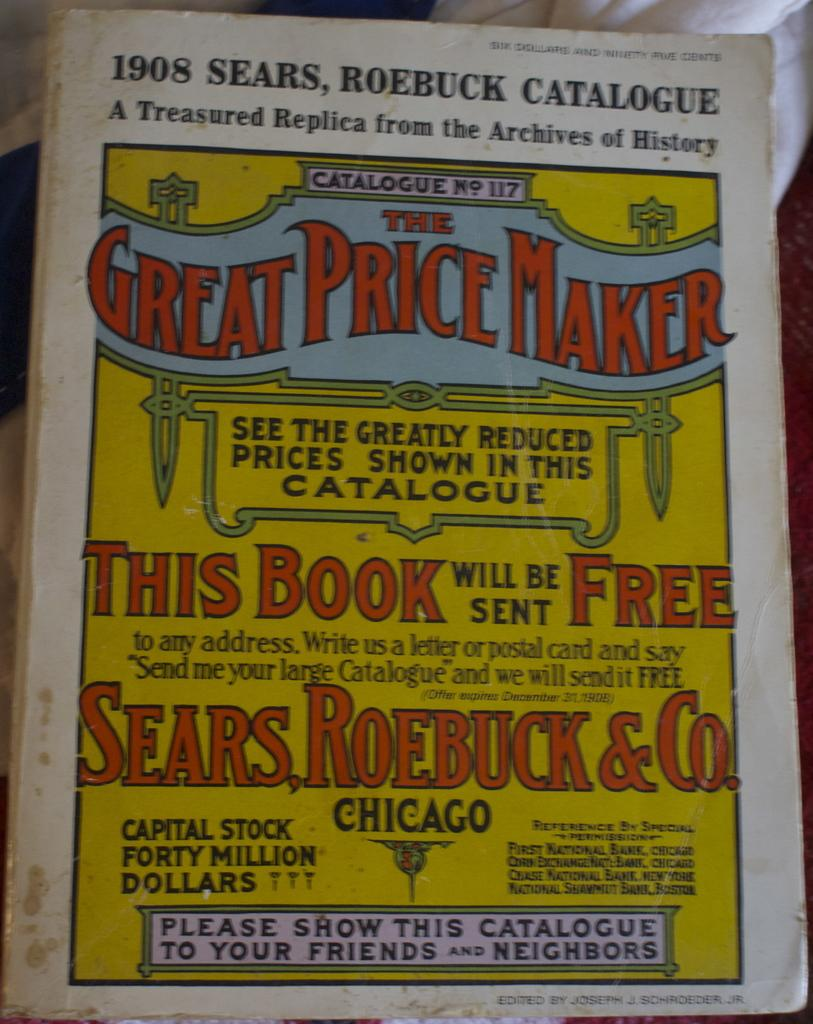What object can be seen in the image? There is a book in the image. What is visible on the book? The book has printed text on it. Where is the book located in the image? The book is placed on a surface. Who is the owner of the cactus in the image? There is no cactus present in the image. 